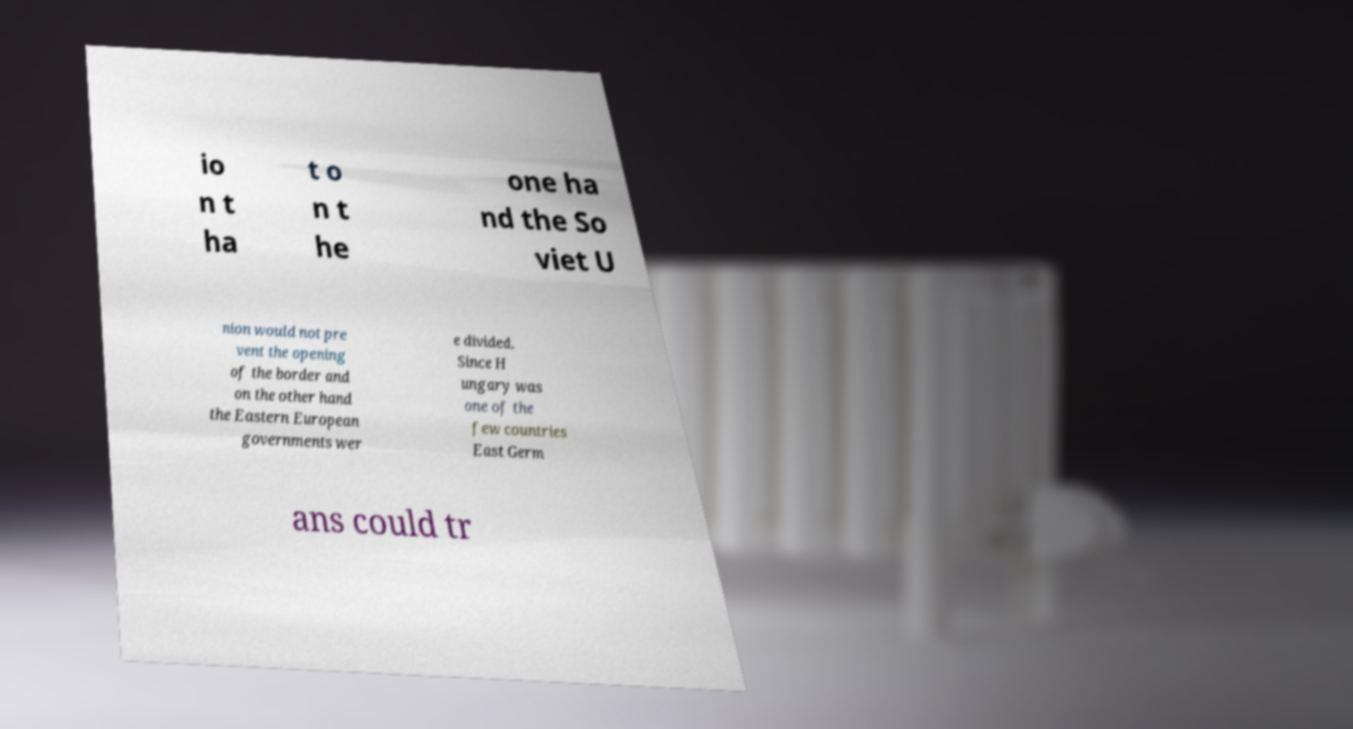What messages or text are displayed in this image? I need them in a readable, typed format. io n t ha t o n t he one ha nd the So viet U nion would not pre vent the opening of the border and on the other hand the Eastern European governments wer e divided. Since H ungary was one of the few countries East Germ ans could tr 